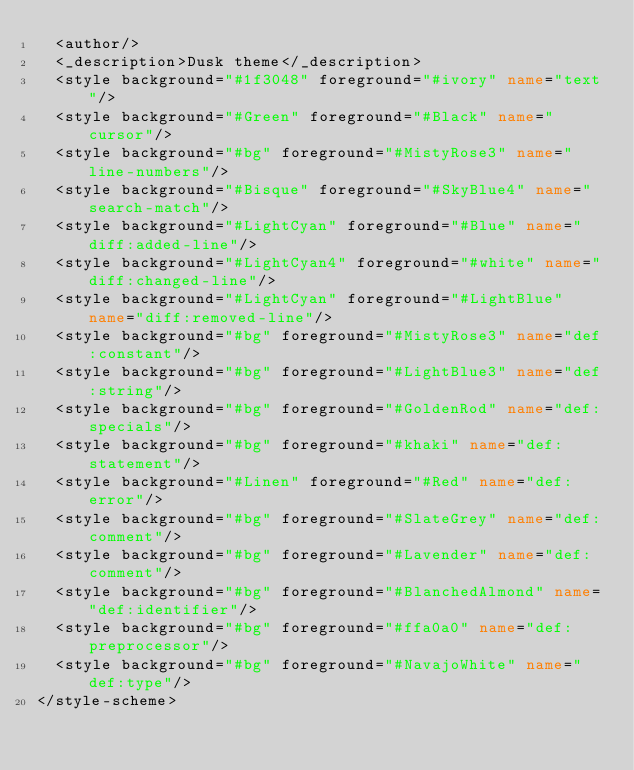<code> <loc_0><loc_0><loc_500><loc_500><_XML_>	<author/>
	<_description>Dusk theme</_description>
	<style background="#1f3048" foreground="#ivory" name="text"/>
	<style background="#Green" foreground="#Black" name="cursor"/>
	<style background="#bg" foreground="#MistyRose3" name="line-numbers"/>
	<style background="#Bisque" foreground="#SkyBlue4" name="search-match"/>
	<style background="#LightCyan" foreground="#Blue" name="diff:added-line"/>
	<style background="#LightCyan4" foreground="#white" name="diff:changed-line"/>
	<style background="#LightCyan" foreground="#LightBlue" name="diff:removed-line"/>
	<style background="#bg" foreground="#MistyRose3" name="def:constant"/>
	<style background="#bg" foreground="#LightBlue3" name="def:string"/>
	<style background="#bg" foreground="#GoldenRod" name="def:specials"/>
	<style background="#bg" foreground="#khaki" name="def:statement"/>
	<style background="#Linen" foreground="#Red" name="def:error"/>
	<style background="#bg" foreground="#SlateGrey" name="def:comment"/>
	<style background="#bg" foreground="#Lavender" name="def:comment"/>
	<style background="#bg" foreground="#BlanchedAlmond" name="def:identifier"/>
	<style background="#bg" foreground="#ffa0a0" name="def:preprocessor"/>
	<style background="#bg" foreground="#NavajoWhite" name="def:type"/>
</style-scheme>

</code> 